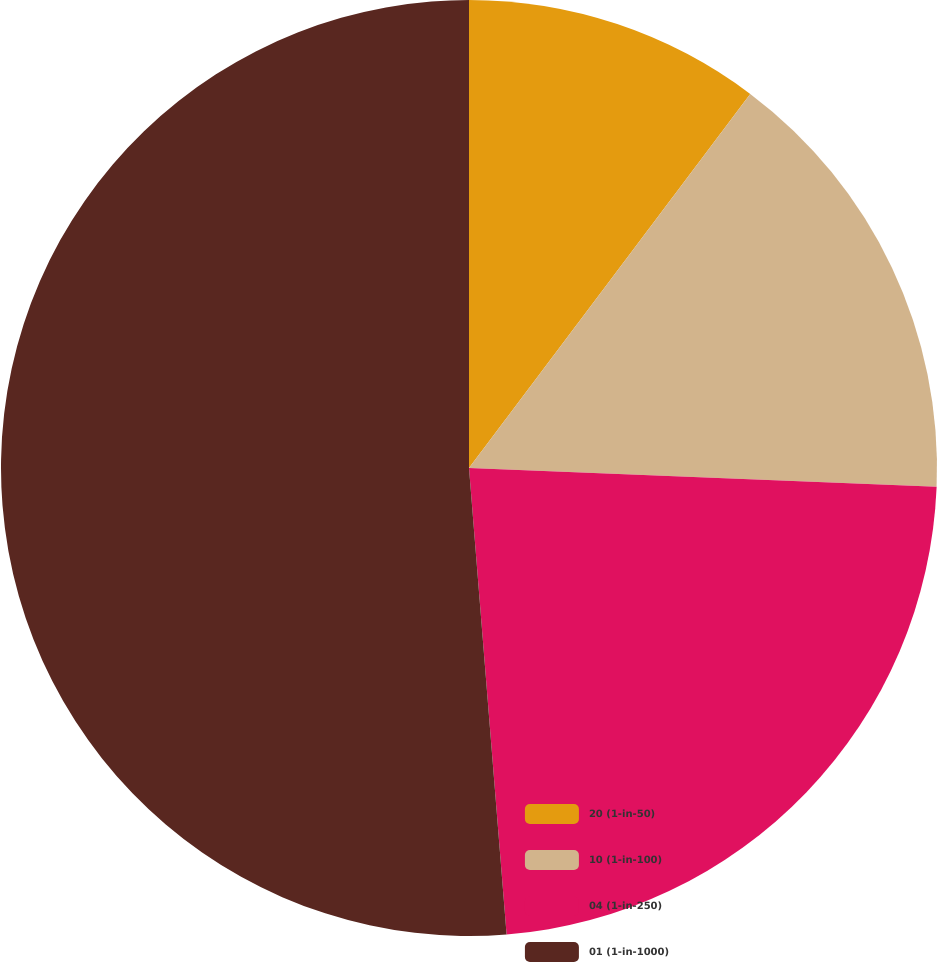<chart> <loc_0><loc_0><loc_500><loc_500><pie_chart><fcel>20 (1-in-50)<fcel>10 (1-in-100)<fcel>04 (1-in-250)<fcel>01 (1-in-1000)<nl><fcel>10.26%<fcel>15.38%<fcel>23.08%<fcel>51.28%<nl></chart> 